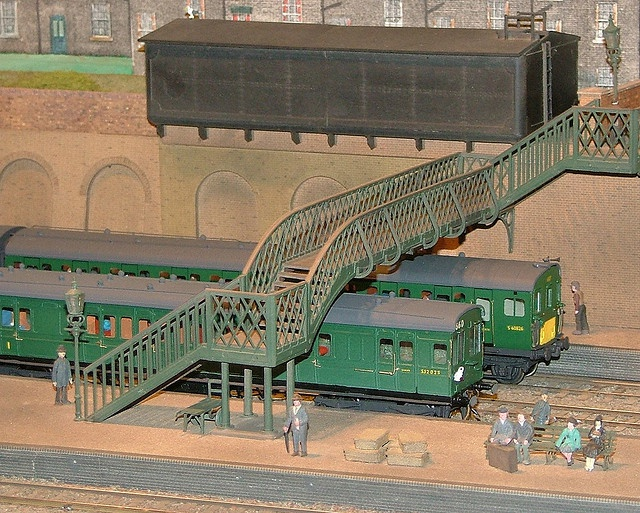Describe the objects in this image and their specific colors. I can see train in gray, darkgreen, and teal tones, train in gray and darkgreen tones, bench in gray and darkgray tones, people in gray and darkgray tones, and people in gray, darkgray, and white tones in this image. 